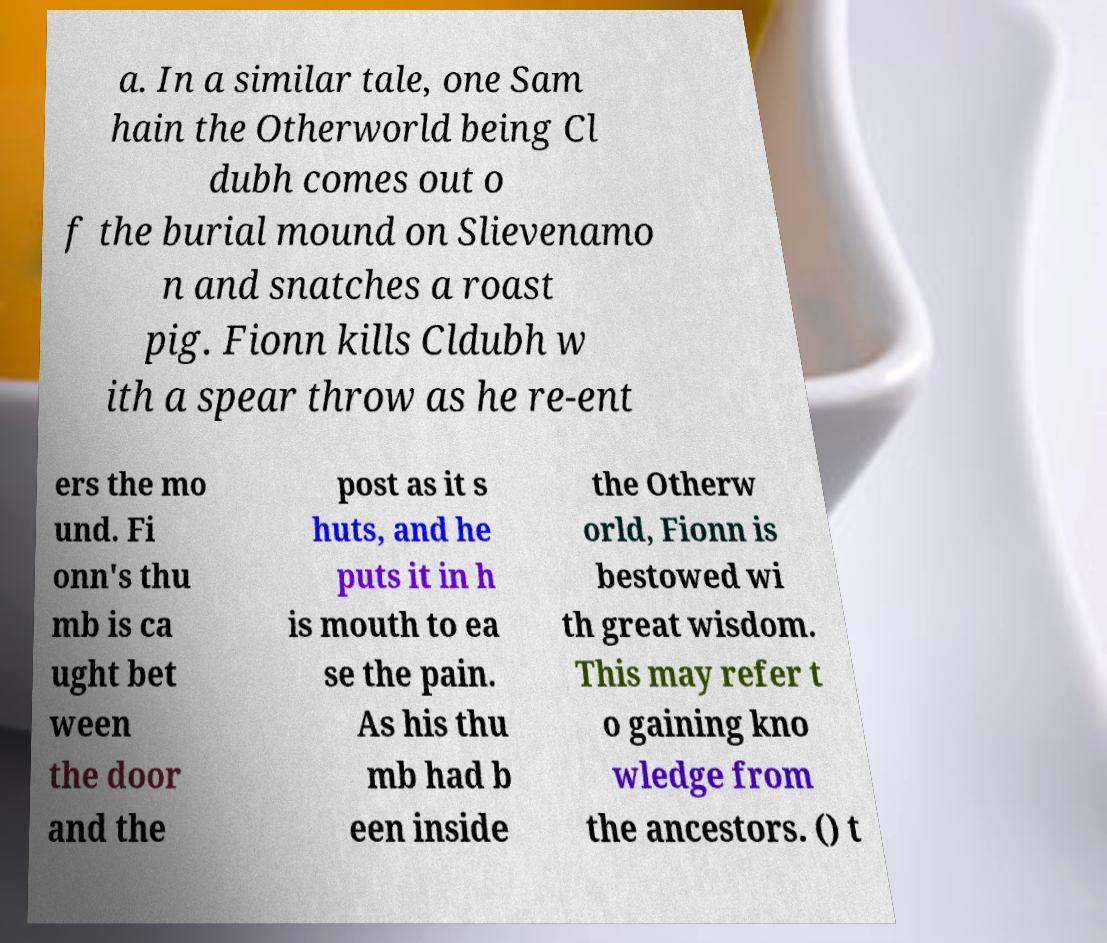What messages or text are displayed in this image? I need them in a readable, typed format. a. In a similar tale, one Sam hain the Otherworld being Cl dubh comes out o f the burial mound on Slievenamo n and snatches a roast pig. Fionn kills Cldubh w ith a spear throw as he re-ent ers the mo und. Fi onn's thu mb is ca ught bet ween the door and the post as it s huts, and he puts it in h is mouth to ea se the pain. As his thu mb had b een inside the Otherw orld, Fionn is bestowed wi th great wisdom. This may refer t o gaining kno wledge from the ancestors. () t 